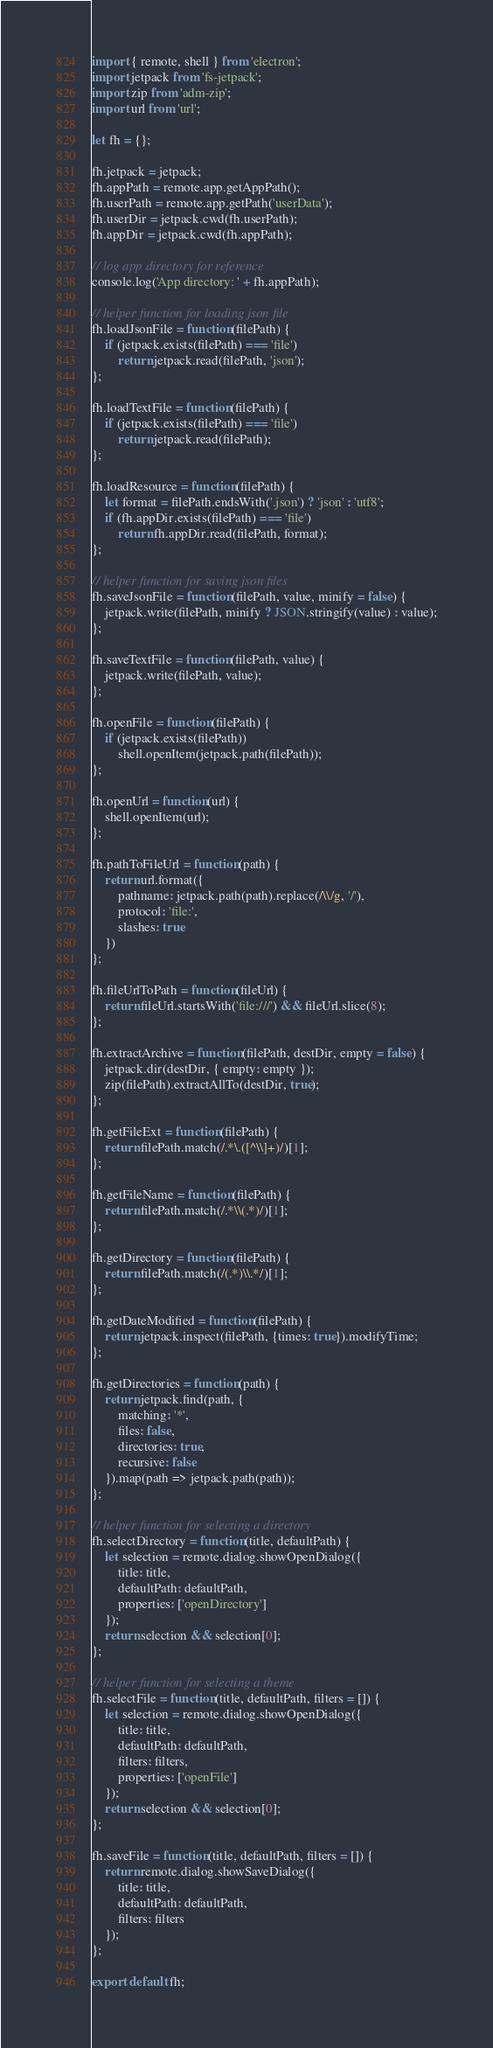<code> <loc_0><loc_0><loc_500><loc_500><_JavaScript_>import { remote, shell } from 'electron';
import jetpack from 'fs-jetpack';
import zip from 'adm-zip';
import url from 'url';

let fh = {};

fh.jetpack = jetpack;
fh.appPath = remote.app.getAppPath();
fh.userPath = remote.app.getPath('userData');
fh.userDir = jetpack.cwd(fh.userPath);
fh.appDir = jetpack.cwd(fh.appPath);

// log app directory for reference
console.log('App directory: ' + fh.appPath);

// helper function for loading json file
fh.loadJsonFile = function(filePath) {
    if (jetpack.exists(filePath) === 'file')
        return jetpack.read(filePath, 'json');
};

fh.loadTextFile = function(filePath) {
    if (jetpack.exists(filePath) === 'file')
        return jetpack.read(filePath);
};

fh.loadResource = function(filePath) {
    let format = filePath.endsWith('.json') ? 'json' : 'utf8';
    if (fh.appDir.exists(filePath) === 'file')
        return fh.appDir.read(filePath, format);
};

// helper function for saving json files
fh.saveJsonFile = function(filePath, value, minify = false) {
    jetpack.write(filePath, minify ? JSON.stringify(value) : value);
};

fh.saveTextFile = function(filePath, value) {
    jetpack.write(filePath, value);
};

fh.openFile = function(filePath) {
    if (jetpack.exists(filePath))
        shell.openItem(jetpack.path(filePath));
};

fh.openUrl = function(url) {
    shell.openItem(url);
};

fh.pathToFileUrl = function(path) {
    return url.format({
        pathname: jetpack.path(path).replace(/\\/g, '/'),
        protocol: 'file:',
        slashes: true
    })
};

fh.fileUrlToPath = function(fileUrl) {
    return fileUrl.startsWith('file:///') && fileUrl.slice(8);
};

fh.extractArchive = function(filePath, destDir, empty = false) {
    jetpack.dir(destDir, { empty: empty });
    zip(filePath).extractAllTo(destDir, true);
};

fh.getFileExt = function(filePath) {
    return filePath.match(/.*\.([^\\]+)/)[1];
};

fh.getFileName = function(filePath) {
    return filePath.match(/.*\\(.*)/)[1];
};

fh.getDirectory = function(filePath) {
    return filePath.match(/(.*)\\.*/)[1];
};

fh.getDateModified = function(filePath) {
    return jetpack.inspect(filePath, {times: true}).modifyTime;
};

fh.getDirectories = function(path) {
    return jetpack.find(path, {
        matching: '*',
        files: false,
        directories: true,
        recursive: false
    }).map(path => jetpack.path(path));
};

// helper function for selecting a directory
fh.selectDirectory = function(title, defaultPath) {
    let selection = remote.dialog.showOpenDialog({
        title: title,
        defaultPath: defaultPath,
        properties: ['openDirectory']
    });
    return selection && selection[0];
};

// helper function for selecting a theme
fh.selectFile = function(title, defaultPath, filters = []) {
    let selection = remote.dialog.showOpenDialog({
        title: title,
        defaultPath: defaultPath,
        filters: filters,
        properties: ['openFile']
    });
    return selection && selection[0];
};

fh.saveFile = function(title, defaultPath, filters = []) {
    return remote.dialog.showSaveDialog({
        title: title,
        defaultPath: defaultPath,
        filters: filters
    });
};

export default fh;
</code> 